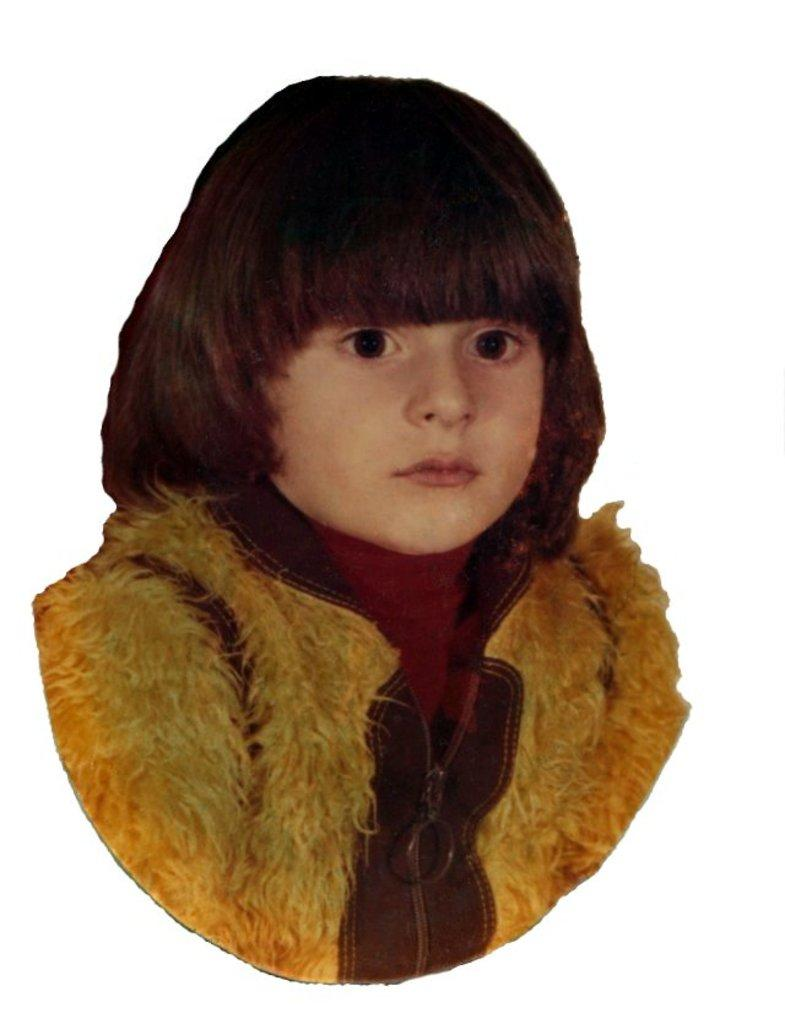What is the main subject of the image? The main subject of the image is a kid. What is the kid wearing in the image? The kid is wearing a jacket in the image. How is the image of the kid depicted? The image is an outline of the kid. What level of difficulty does the kid face in the image? The image does not depict any difficulty level or challenge; it is simply an outline of the kid wearing a jacket. 